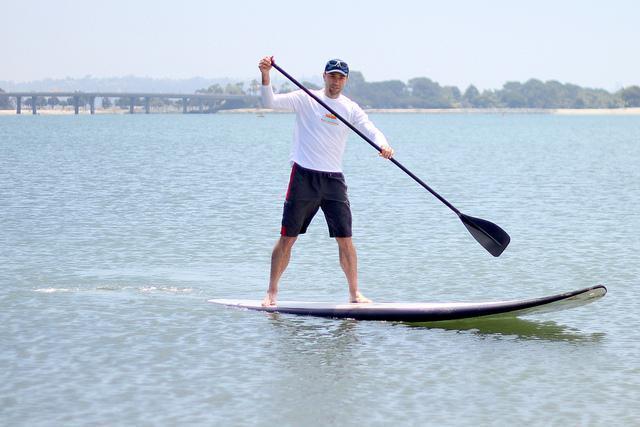How many of these elephants look like they are babies?
Give a very brief answer. 0. 